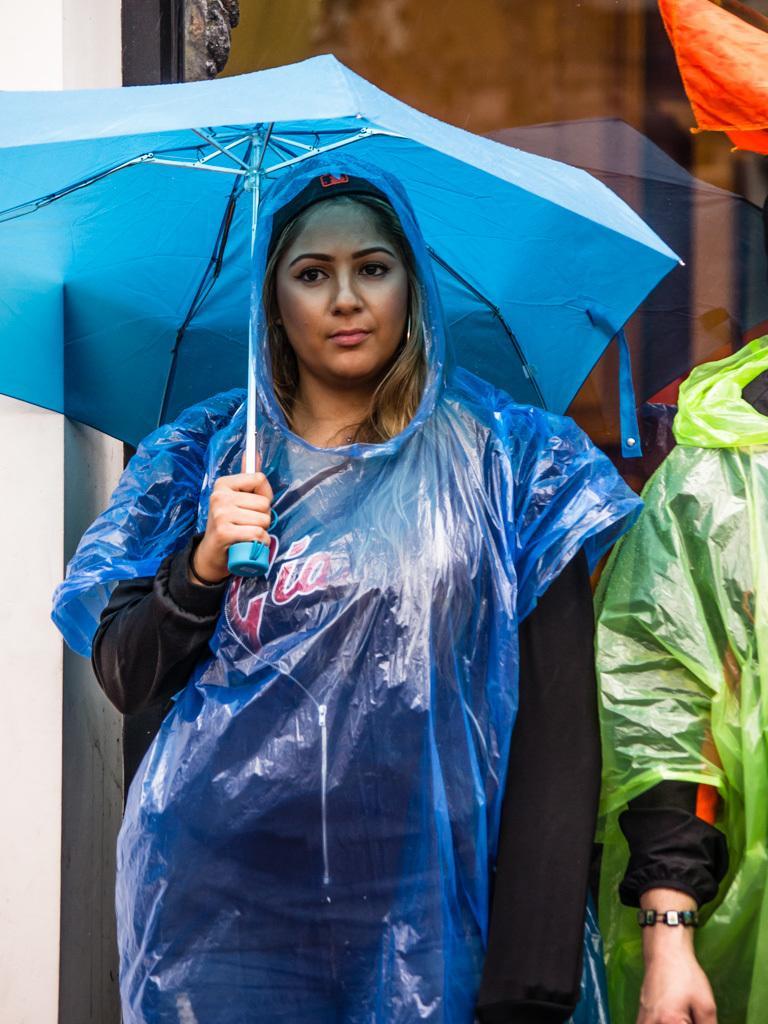How would you summarize this image in a sentence or two? In this image there is a woman wearing a raincoat, holding an umbrella. Beside the woman there is another person wearing a raincoat. 